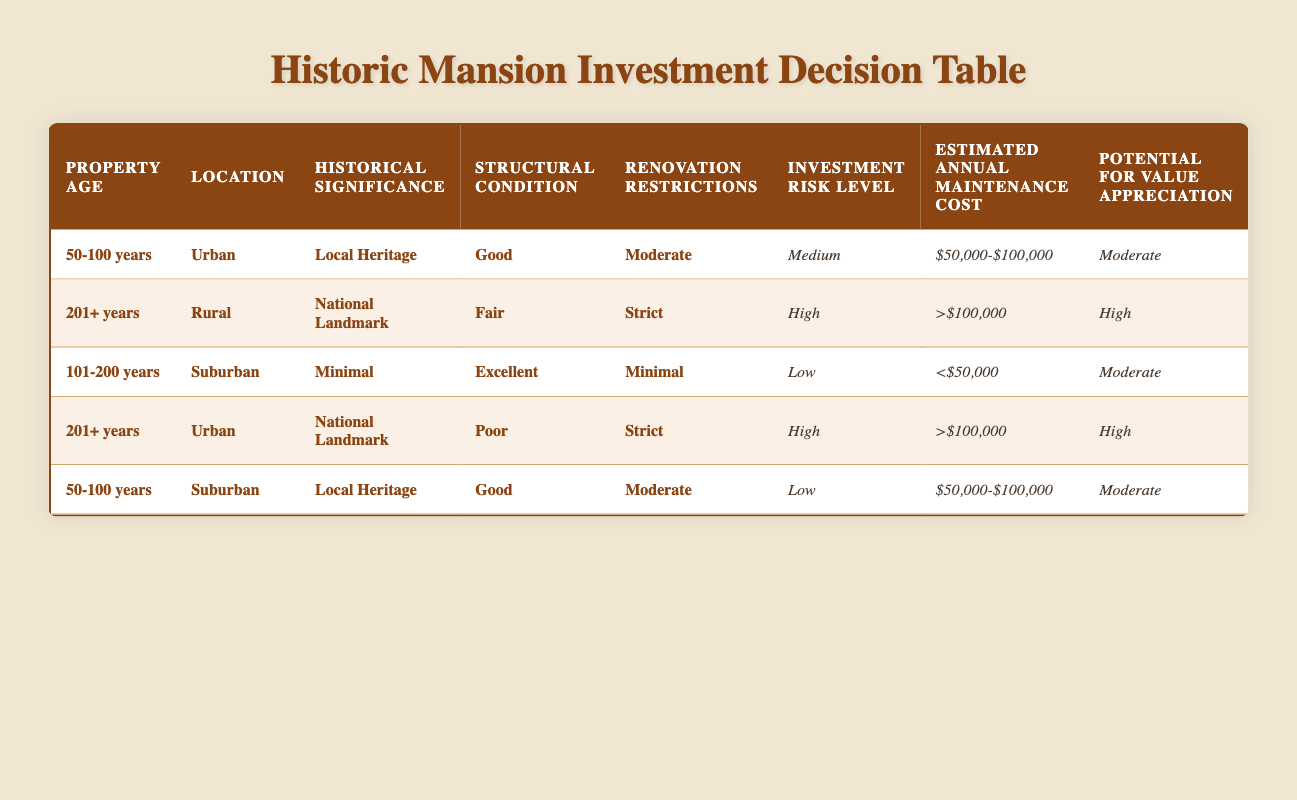What is the investment risk level for a property aged 201+ years located in Urban with Poor structural condition? Referring to the table, the row corresponding to 201+ years, Urban, and Poor structural condition shows an investment risk level of High.
Answer: High What is the estimated annual maintenance cost for properties with a historical significance of National Landmark and renovation restrictions classified as Strict? From the table, there are two entries with historical significance of National Landmark and Strict renovation restrictions: one has a maintenance cost of >$100,000 (201+ years, Rural) and the other also has >$100,000 (201+ years, Urban). Both options agree, thus the answer is the same for both.
Answer: >$100,000 Are properties older than 100 years generally considered medium risk? Looking at all table entries for properties older than 100 years, we find two properties (201+ years, Rural and Urban with Poor/Fair) that have High risk. The remaining property (101-200 years, Suburban) is Low risk. This indicates that properties over 100 years old can be High risk.
Answer: No What is the potential for value appreciation for properties aged 50-100 years in Suburban areas with Local Heritage? In the table, there is an entry for 50-100 years, Suburban, Local Heritage that indicates a potential for value appreciation of Moderate.
Answer: Moderate What is the average estimated annual maintenance cost across all properties listed in the table? The estimated annual maintenance costs listed are <$50,000, $50,000-$100,000, and >$100,000. To find the average, we convert each into a representative value: assuming $25,000 for <50,000, $75,000 for $50,000-$100,000, and $110,000 for >$100,000. The average is calculated: (25,000 + 75,000 + 110,000 + 75,000 + 110,000) / 5 = 79,000.
Answer: $79,000 Is it true that all properties with a poor structural condition also have high investment risk? Checking the rows for Poor structural condition, there are properties that display High investment risk, but not all. The property aged 50-100 years and Suburban has Low risk. Therefore, not all Poor conditions signify High risk.
Answer: No What condition and renovation restrictions correspond to a Low investment risk? The table shows that the property aged 101-200 years in Suburban areas with Minimal historical significance, Excellent condition, and Minimal renovation restrictions indicates Low investment risk.
Answer: Excellent, Minimal If a property is a National Landmark with Fair structural condition, what is its potential for value appreciation? In the row for 201+ years, Rural, National Landmark with Fair condition, the potential for value appreciation is High according to the table.
Answer: High How many properties have a significant tax benefit as indicated in the table? Reviewing the table specifically for the Tax Benefits category, there are two properties that show Significant tax benefits: the 201+ years, Rural, and both 201+ years, Urban properties. Thus, the total is two.
Answer: Two 